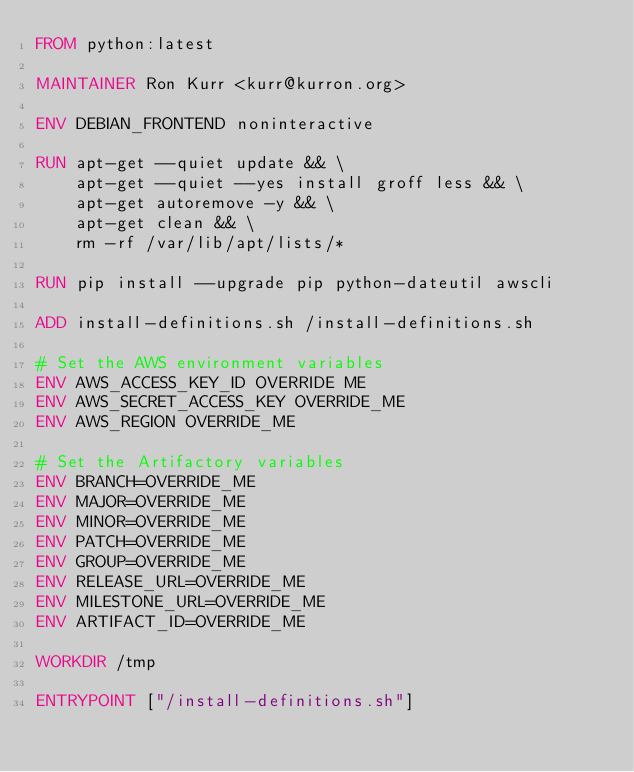<code> <loc_0><loc_0><loc_500><loc_500><_Dockerfile_>FROM python:latest

MAINTAINER Ron Kurr <kurr@kurron.org>

ENV DEBIAN_FRONTEND noninteractive

RUN apt-get --quiet update && \
    apt-get --quiet --yes install groff less && \
    apt-get autoremove -y && \
    apt-get clean && \
    rm -rf /var/lib/apt/lists/*

RUN pip install --upgrade pip python-dateutil awscli

ADD install-definitions.sh /install-definitions.sh

# Set the AWS environment variables
ENV AWS_ACCESS_KEY_ID OVERRIDE ME 
ENV AWS_SECRET_ACCESS_KEY OVERRIDE_ME
ENV AWS_REGION OVERRIDE_ME 

# Set the Artifactory variables 
ENV BRANCH=OVERRIDE_ME
ENV MAJOR=OVERRIDE_ME
ENV MINOR=OVERRIDE_ME
ENV PATCH=OVERRIDE_ME
ENV GROUP=OVERRIDE_ME
ENV RELEASE_URL=OVERRIDE_ME
ENV MILESTONE_URL=OVERRIDE_ME
ENV ARTIFACT_ID=OVERRIDE_ME

WORKDIR /tmp

ENTRYPOINT ["/install-definitions.sh"]
</code> 